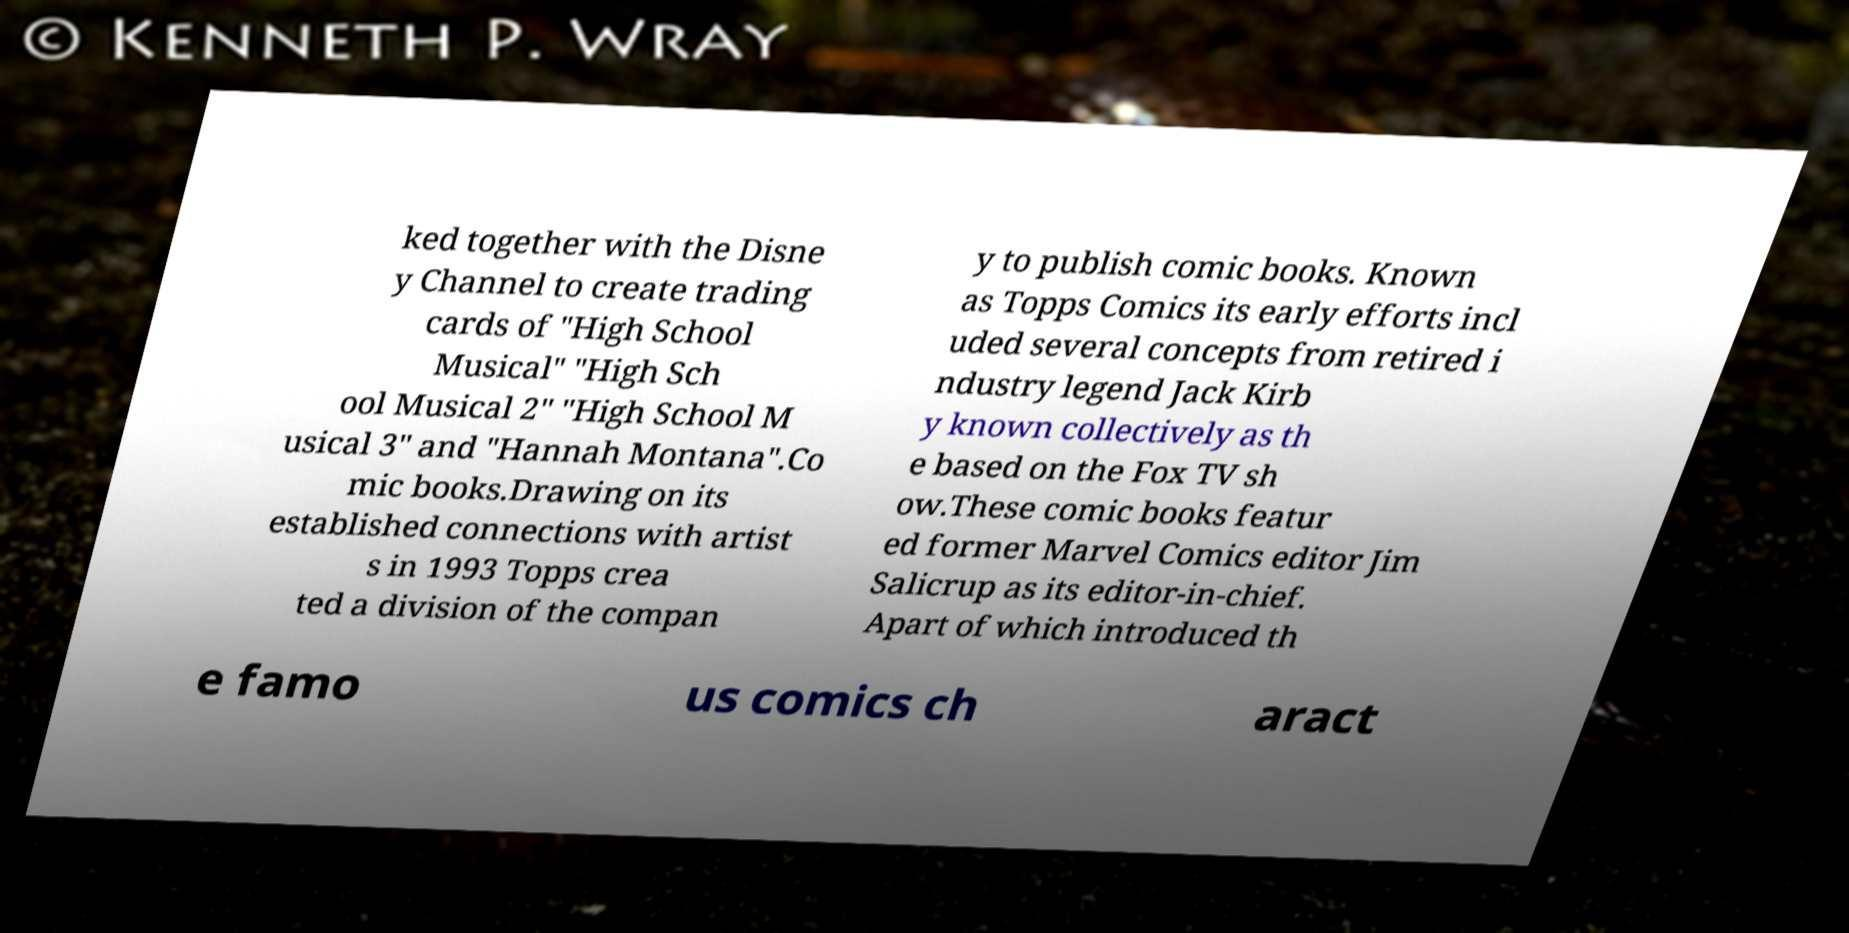Can you read and provide the text displayed in the image?This photo seems to have some interesting text. Can you extract and type it out for me? ked together with the Disne y Channel to create trading cards of "High School Musical" "High Sch ool Musical 2" "High School M usical 3" and "Hannah Montana".Co mic books.Drawing on its established connections with artist s in 1993 Topps crea ted a division of the compan y to publish comic books. Known as Topps Comics its early efforts incl uded several concepts from retired i ndustry legend Jack Kirb y known collectively as th e based on the Fox TV sh ow.These comic books featur ed former Marvel Comics editor Jim Salicrup as its editor-in-chief. Apart of which introduced th e famo us comics ch aract 